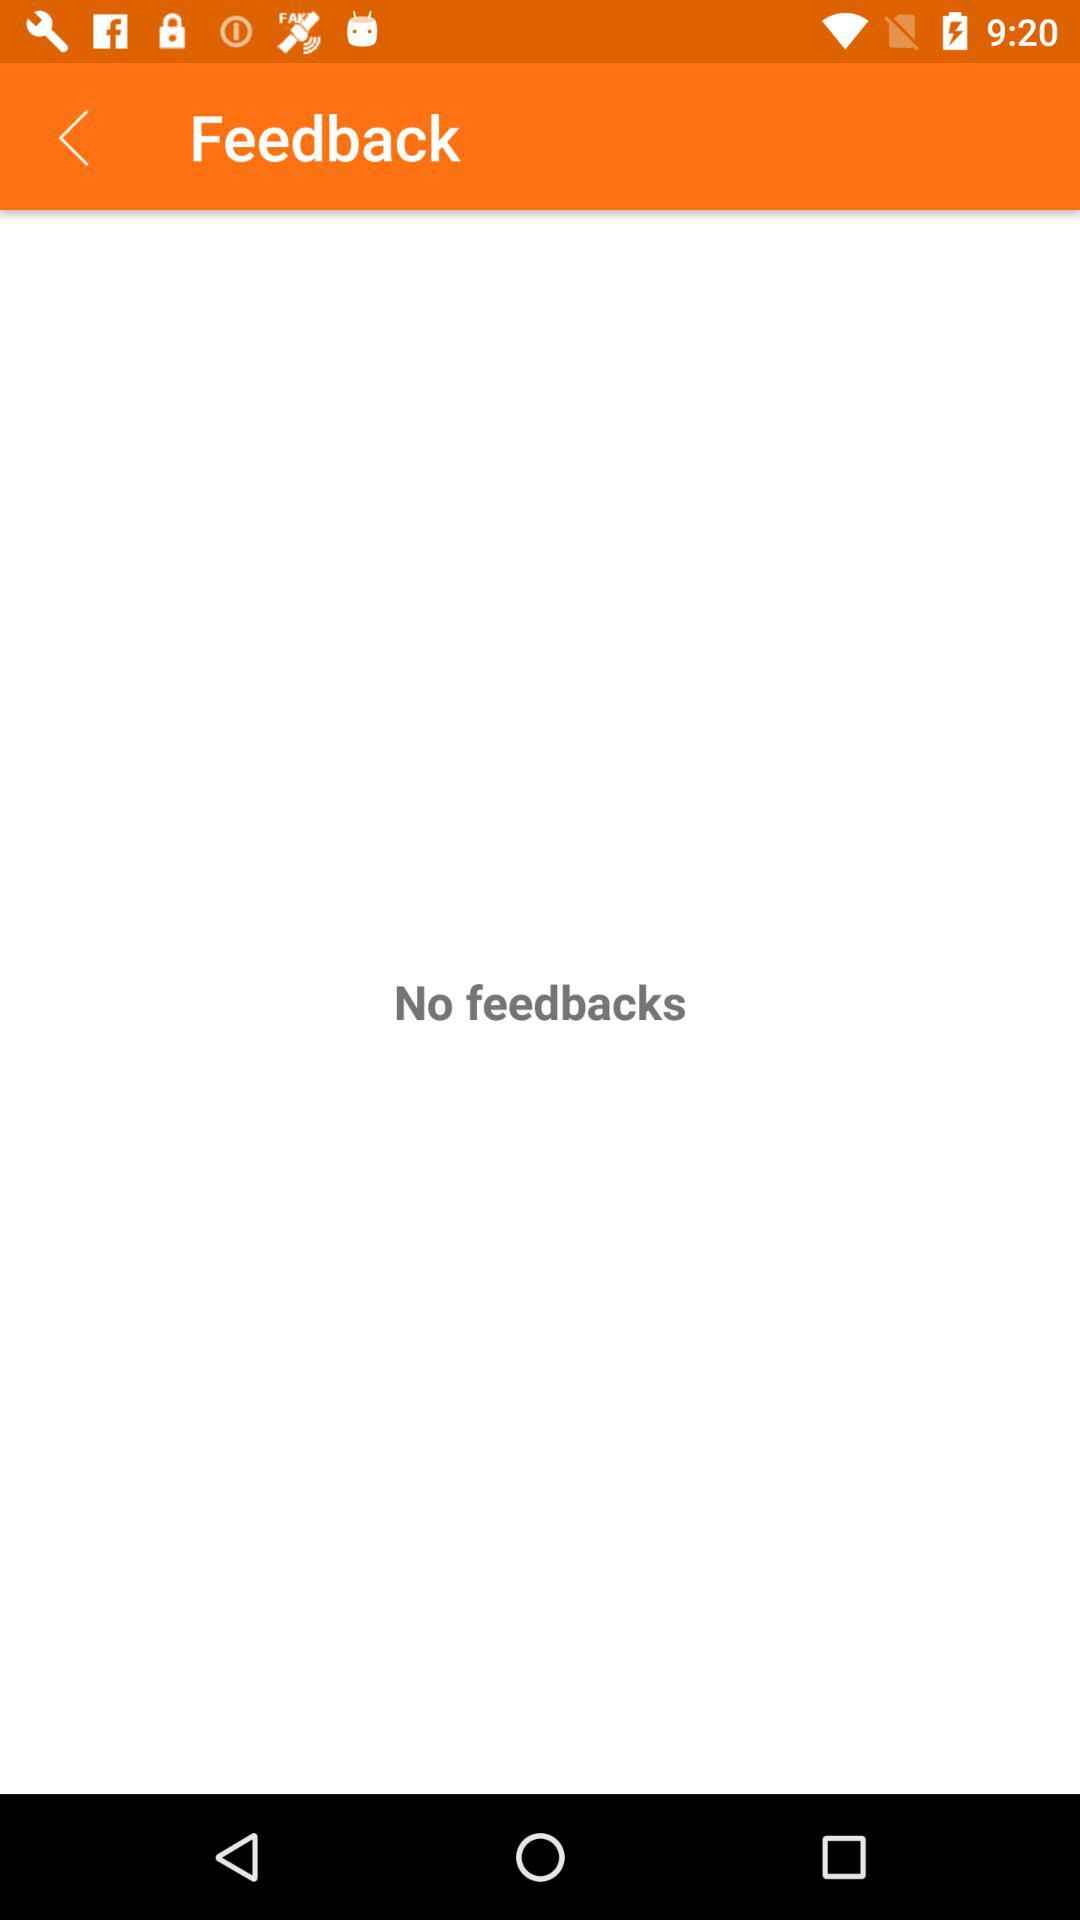Is there any feedback? There is no feedback. 